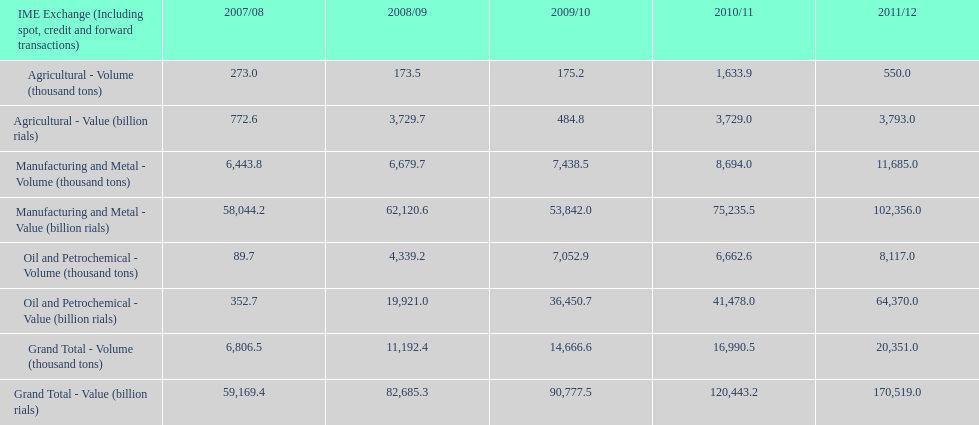In which year was the greatest agricultural production? 2010/11. 